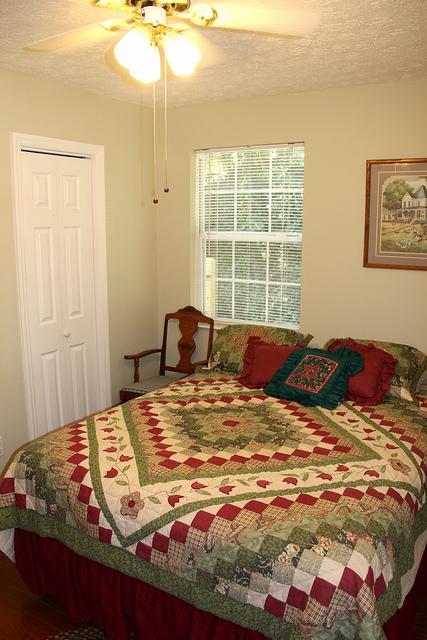How many cushions are on the bed?
Keep it brief. 5. Is this someone's house?
Short answer required. Yes. How big is this bed?
Concise answer only. Queen. What kind of light fixture is shown?
Quick response, please. Ceiling fan. 